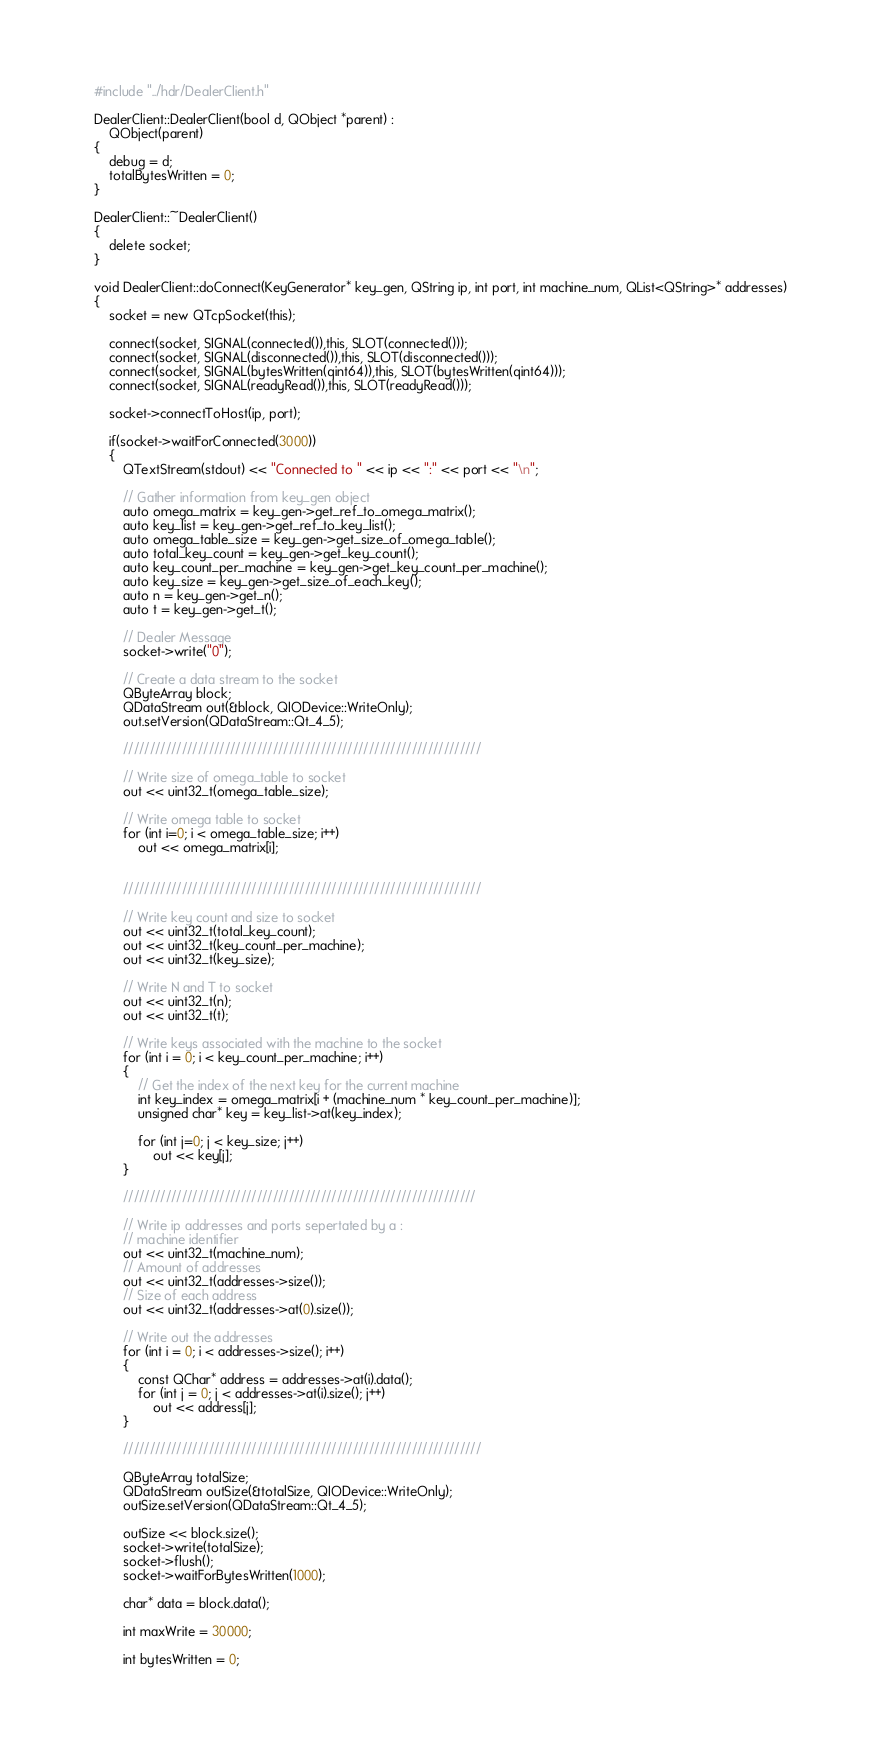Convert code to text. <code><loc_0><loc_0><loc_500><loc_500><_C++_>#include "../hdr/DealerClient.h"

DealerClient::DealerClient(bool d, QObject *parent) :
    QObject(parent)
{
    debug = d;
    totalBytesWritten = 0;
}

DealerClient::~DealerClient()
{
    delete socket;    
}

void DealerClient::doConnect(KeyGenerator* key_gen, QString ip, int port, int machine_num, QList<QString>* addresses)
{
    socket = new QTcpSocket(this);

    connect(socket, SIGNAL(connected()),this, SLOT(connected()));
    connect(socket, SIGNAL(disconnected()),this, SLOT(disconnected()));
    connect(socket, SIGNAL(bytesWritten(qint64)),this, SLOT(bytesWritten(qint64)));
    connect(socket, SIGNAL(readyRead()),this, SLOT(readyRead()));

    socket->connectToHost(ip, port);

    if(socket->waitForConnected(3000))
    {
        QTextStream(stdout) << "Connected to " << ip << ":" << port << "\n";

        // Gather information from key_gen object
        auto omega_matrix = key_gen->get_ref_to_omega_matrix();
        auto key_list = key_gen->get_ref_to_key_list();
        auto omega_table_size = key_gen->get_size_of_omega_table();
        auto total_key_count = key_gen->get_key_count();
        auto key_count_per_machine = key_gen->get_key_count_per_machine();
        auto key_size = key_gen->get_size_of_each_key();
        auto n = key_gen->get_n();
        auto t = key_gen->get_t();

        // Dealer Message
        socket->write("0");

        // Create a data stream to the socket
        QByteArray block;
        QDataStream out(&block, QIODevice::WriteOnly);
        out.setVersion(QDataStream::Qt_4_5);

        ///////////////////////////////////////////////////////////////////

        // Write size of omega_table to socket
        out << uint32_t(omega_table_size);
        
        // Write omega table to socket
        for (int i=0; i < omega_table_size; i++)
            out << omega_matrix[i];
        
        
        ///////////////////////////////////////////////////////////////////

        // Write key count and size to socket
        out << uint32_t(total_key_count);
        out << uint32_t(key_count_per_machine);
        out << uint32_t(key_size);

        // Write N and T to socket
        out << uint32_t(n);
        out << uint32_t(t);

        // Write keys associated with the machine to the socket
        for (int i = 0; i < key_count_per_machine; i++)
        {
            // Get the index of the next key for the current machine
            int key_index = omega_matrix[i + (machine_num * key_count_per_machine)];
            unsigned char* key = key_list->at(key_index);

            for (int j=0; j < key_size; j++)
                out << key[j];
        }

        //////////////////////////////////////////////////////////////////

        // Write ip addresses and ports sepertated by a :
        // machine identifier
        out << uint32_t(machine_num);
        // Amount of addresses
        out << uint32_t(addresses->size());
        // Size of each address
        out << uint32_t(addresses->at(0).size());

        // Write out the addresses
        for (int i = 0; i < addresses->size(); i++)
        {
            const QChar* address = addresses->at(i).data();
            for (int j = 0; j < addresses->at(i).size(); j++)
                out << address[j];
        }

        ///////////////////////////////////////////////////////////////////

        QByteArray totalSize;
        QDataStream outSize(&totalSize, QIODevice::WriteOnly);
        outSize.setVersion(QDataStream::Qt_4_5);

        outSize << block.size();
        socket->write(totalSize);
        socket->flush();
        socket->waitForBytesWritten(1000);

        char* data = block.data();

        int maxWrite = 30000;

        int bytesWritten = 0;</code> 